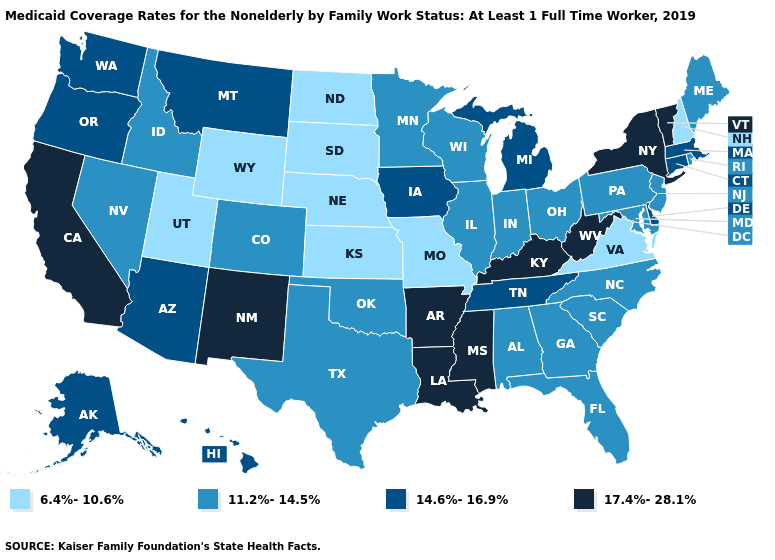Name the states that have a value in the range 14.6%-16.9%?
Give a very brief answer. Alaska, Arizona, Connecticut, Delaware, Hawaii, Iowa, Massachusetts, Michigan, Montana, Oregon, Tennessee, Washington. What is the highest value in the MidWest ?
Short answer required. 14.6%-16.9%. Is the legend a continuous bar?
Answer briefly. No. Which states have the highest value in the USA?
Short answer required. Arkansas, California, Kentucky, Louisiana, Mississippi, New Mexico, New York, Vermont, West Virginia. What is the value of Illinois?
Give a very brief answer. 11.2%-14.5%. Does the first symbol in the legend represent the smallest category?
Write a very short answer. Yes. How many symbols are there in the legend?
Concise answer only. 4. What is the lowest value in states that border North Carolina?
Keep it brief. 6.4%-10.6%. Name the states that have a value in the range 14.6%-16.9%?
Quick response, please. Alaska, Arizona, Connecticut, Delaware, Hawaii, Iowa, Massachusetts, Michigan, Montana, Oregon, Tennessee, Washington. Among the states that border New York , which have the highest value?
Concise answer only. Vermont. Name the states that have a value in the range 11.2%-14.5%?
Concise answer only. Alabama, Colorado, Florida, Georgia, Idaho, Illinois, Indiana, Maine, Maryland, Minnesota, Nevada, New Jersey, North Carolina, Ohio, Oklahoma, Pennsylvania, Rhode Island, South Carolina, Texas, Wisconsin. How many symbols are there in the legend?
Answer briefly. 4. Name the states that have a value in the range 6.4%-10.6%?
Concise answer only. Kansas, Missouri, Nebraska, New Hampshire, North Dakota, South Dakota, Utah, Virginia, Wyoming. Name the states that have a value in the range 11.2%-14.5%?
Keep it brief. Alabama, Colorado, Florida, Georgia, Idaho, Illinois, Indiana, Maine, Maryland, Minnesota, Nevada, New Jersey, North Carolina, Ohio, Oklahoma, Pennsylvania, Rhode Island, South Carolina, Texas, Wisconsin. 